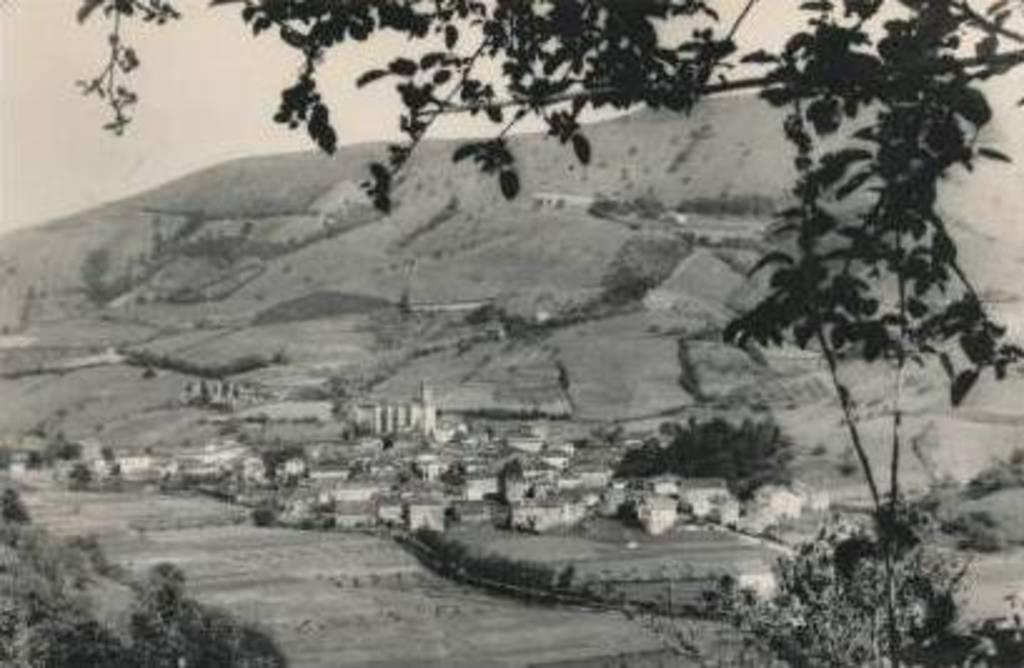What is the color scheme of the image? The image is in black and white. What type of natural environment can be seen in the image? There are trees and hills in the image. What type of human-made structures are visible in the image? There are houses and farmlands in the image. What is visible in the background of the image? The sky is visible in the background of the image. What type of beast can be seen roaming the farmlands in the image? There are no beasts visible in the image; it features trees, hills, houses, and farmlands. What type of frame surrounds the image? The provided facts do not mention any frame surrounding the image. 